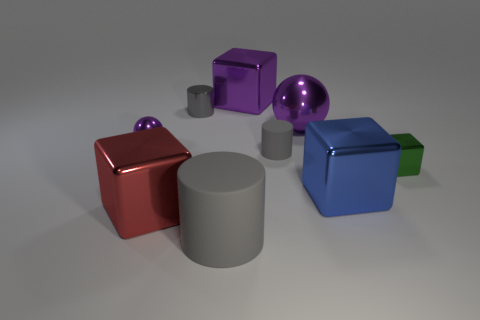How many other objects are the same size as the red block?
Provide a short and direct response. 4. Is the small purple object made of the same material as the big gray object that is in front of the blue metallic cube?
Offer a very short reply. No. What number of objects are either tiny metallic objects that are to the right of the tiny purple ball or big gray cylinders?
Give a very brief answer. 3. Is there a small matte object of the same color as the metal cylinder?
Your answer should be compact. Yes. Do the large gray rubber thing and the gray matte thing that is right of the big gray thing have the same shape?
Your answer should be compact. Yes. How many cubes are both on the right side of the large sphere and behind the tiny gray matte thing?
Your response must be concise. 0. What material is the purple thing that is the same shape as the red metallic thing?
Make the answer very short. Metal. There is a purple object in front of the purple sphere to the right of the large gray matte cylinder; what size is it?
Make the answer very short. Small. Are any small metal blocks visible?
Provide a succinct answer. Yes. What is the material of the big block that is both left of the blue metal object and in front of the tiny ball?
Your answer should be compact. Metal. 